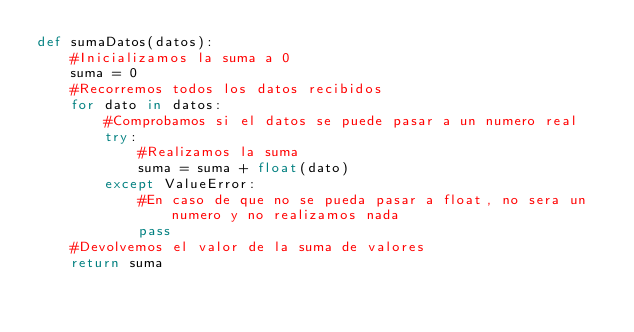Convert code to text. <code><loc_0><loc_0><loc_500><loc_500><_Python_>def sumaDatos(datos):
    #Inicializamos la suma a 0
    suma = 0
    #Recorremos todos los datos recibidos
    for dato in datos:
        #Comprobamos si el datos se puede pasar a un numero real
        try:
            #Realizamos la suma
            suma = suma + float(dato)
        except ValueError:
            #En caso de que no se pueda pasar a float, no sera un numero y no realizamos nada 
            pass  
    #Devolvemos el valor de la suma de valores
    return suma</code> 